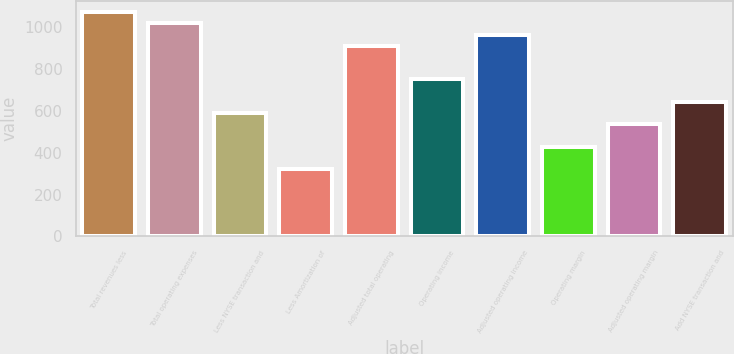Convert chart to OTSL. <chart><loc_0><loc_0><loc_500><loc_500><bar_chart><fcel>Total revenues less<fcel>Total operating expenses<fcel>Less NYSE transaction and<fcel>Less Amortization of<fcel>Adjusted total operating<fcel>Operating income<fcel>Adjusted operating income<fcel>Operating margin<fcel>Adjusted operating margin<fcel>Add NYSE transaction and<nl><fcel>1070.72<fcel>1017.25<fcel>589.49<fcel>322.14<fcel>910.31<fcel>749.9<fcel>963.78<fcel>429.08<fcel>536.02<fcel>642.96<nl></chart> 